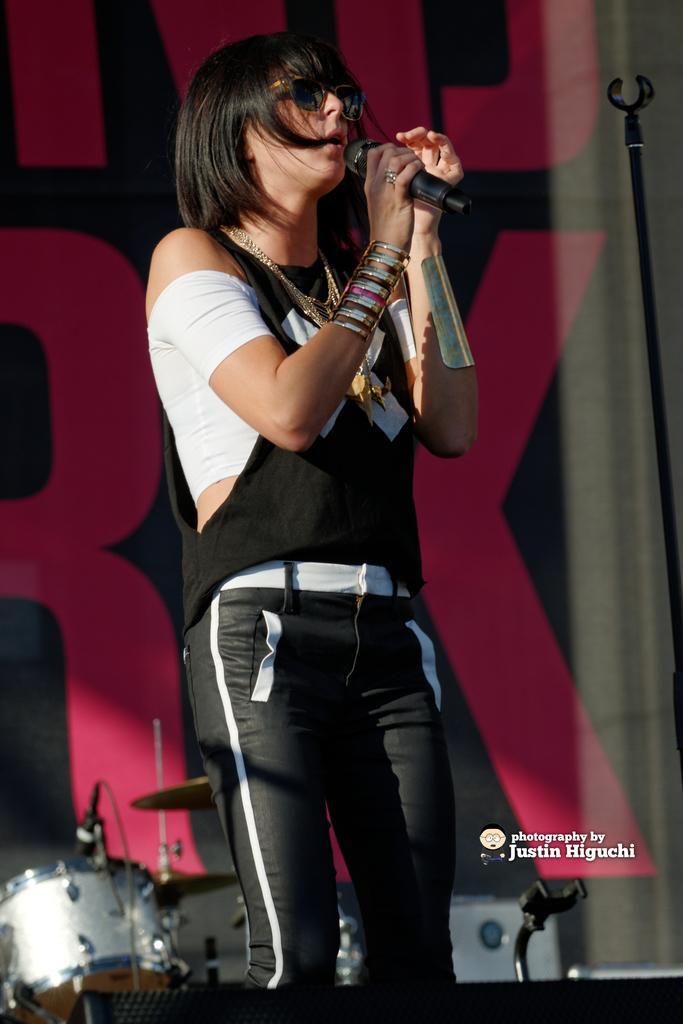How would you summarize this image in a sentence or two? This image might be clicked in a Musical concert. In the bottom left corner there are drums and there is a mic stand top right. There is a woman in the middle of the image ,she is singing something. She wore black dress she wore goggles bracelet chain. 